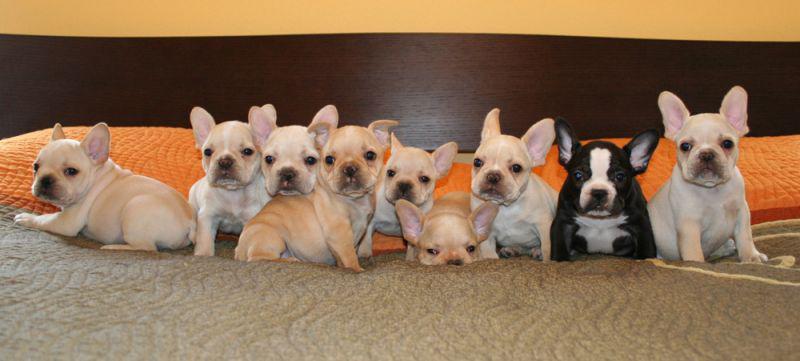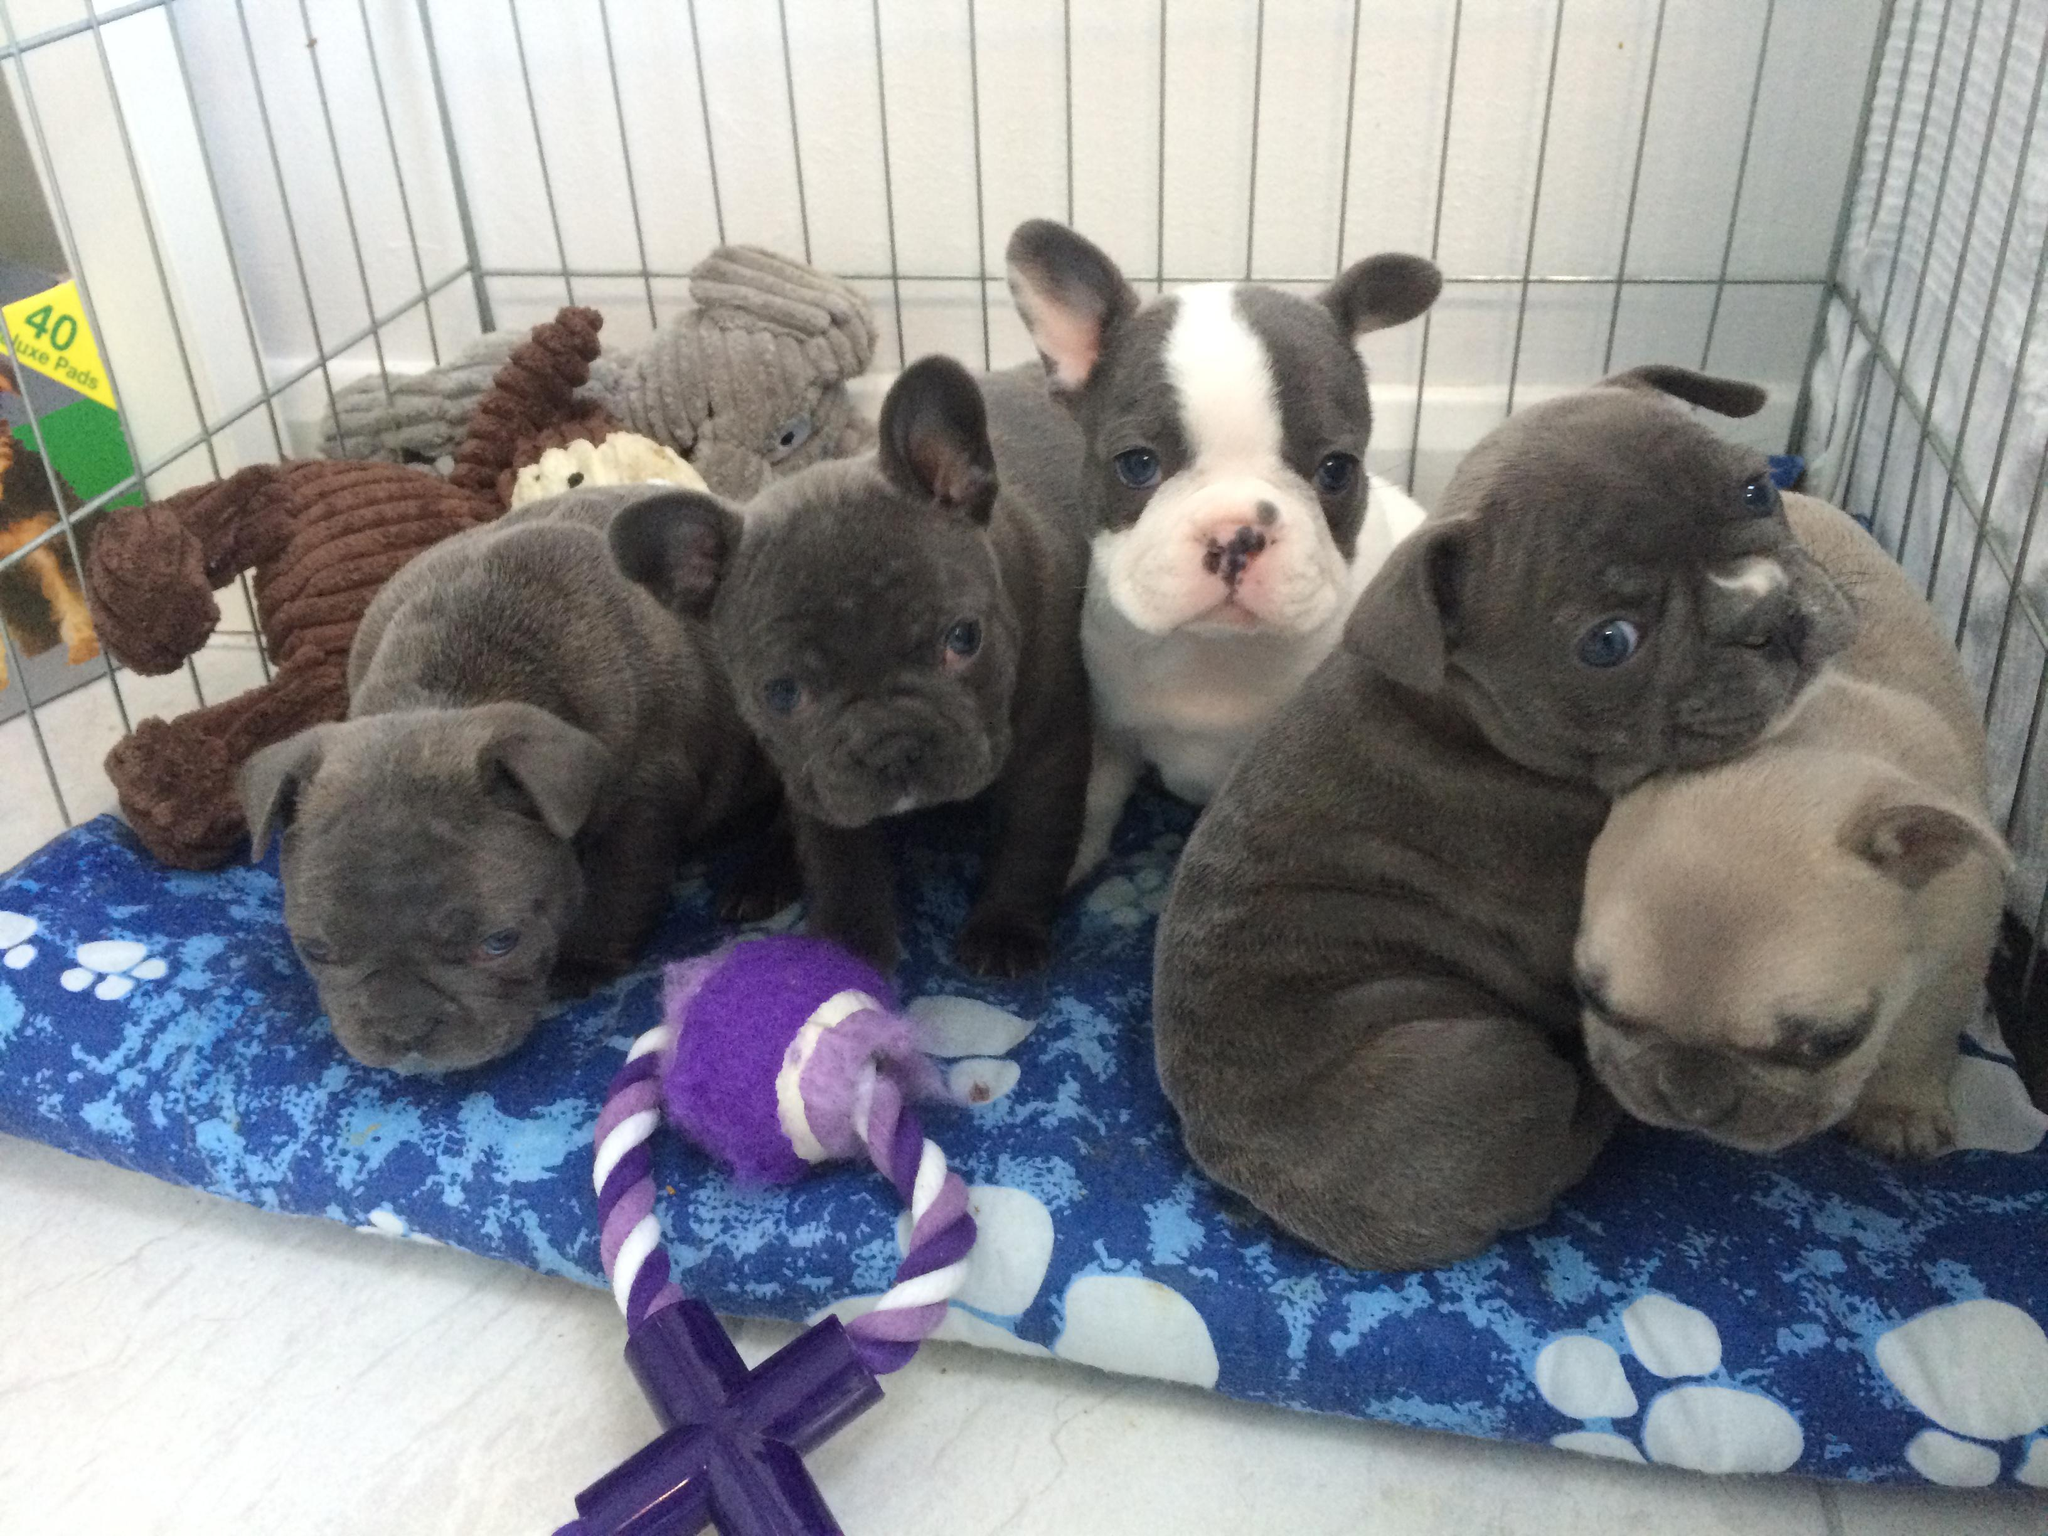The first image is the image on the left, the second image is the image on the right. For the images displayed, is the sentence "There are five puppies in the right image." factually correct? Answer yes or no. Yes. The first image is the image on the left, the second image is the image on the right. Examine the images to the left and right. Is the description "At least one of the images features dogs that are outside." accurate? Answer yes or no. No. 